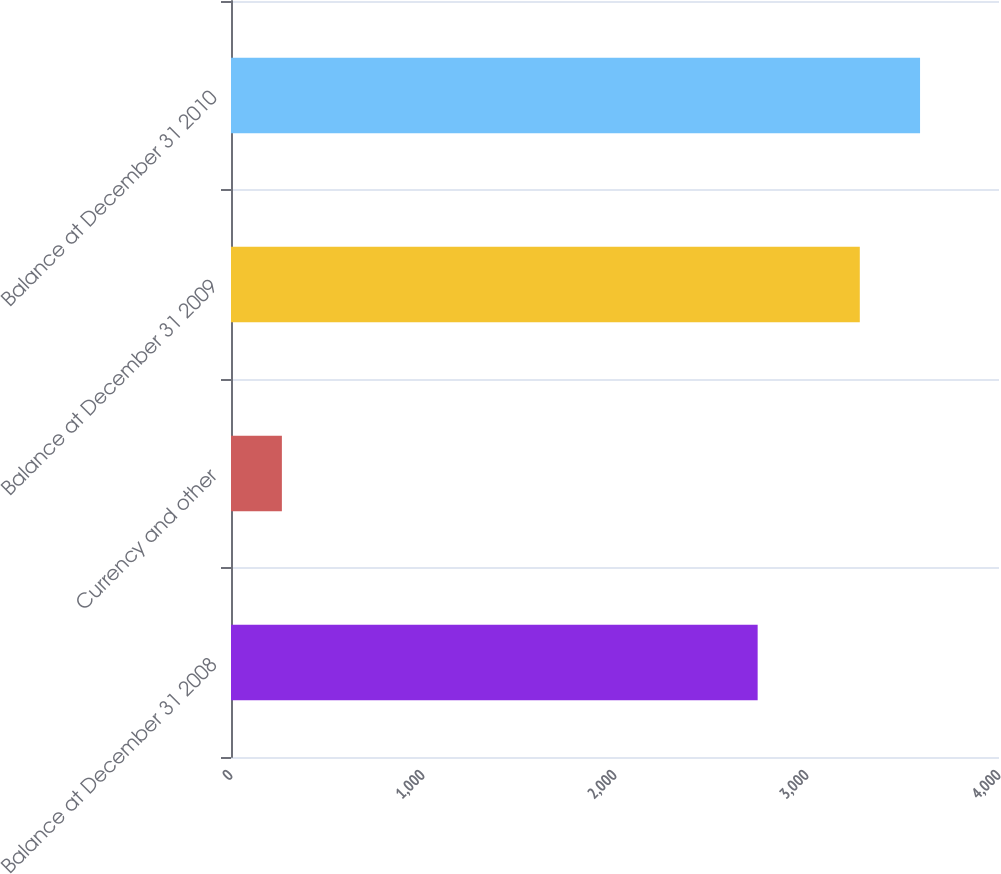Convert chart. <chart><loc_0><loc_0><loc_500><loc_500><bar_chart><fcel>Balance at December 31 2008<fcel>Currency and other<fcel>Balance at December 31 2009<fcel>Balance at December 31 2010<nl><fcel>2743<fcel>265<fcel>3275<fcel>3588.8<nl></chart> 